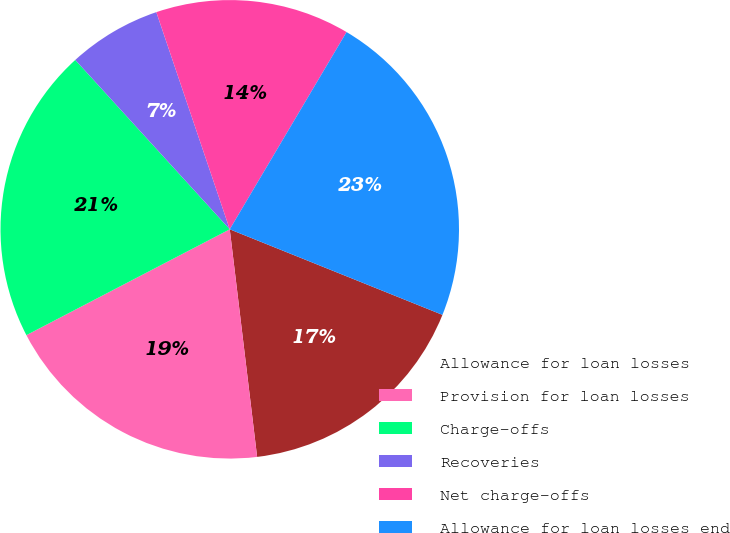Convert chart to OTSL. <chart><loc_0><loc_0><loc_500><loc_500><pie_chart><fcel>Allowance for loan losses<fcel>Provision for loan losses<fcel>Charge-offs<fcel>Recoveries<fcel>Net charge-offs<fcel>Allowance for loan losses end<nl><fcel>17.01%<fcel>19.27%<fcel>20.87%<fcel>6.58%<fcel>13.7%<fcel>22.58%<nl></chart> 